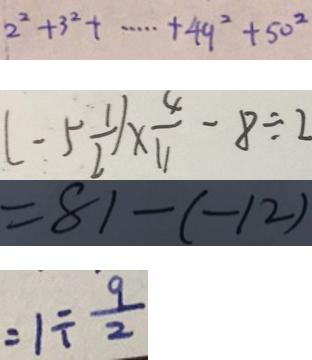Convert formula to latex. <formula><loc_0><loc_0><loc_500><loc_500>2 ^ { 2 } + 3 ^ { 2 } + \cdots + 4 9 ^ { 2 } + 5 0 ^ { 2 } 
 ( - 5 \frac { 1 } { 2 } ) \times \frac { 4 } { 1 1 } - 8 \div 2 
 = 8 1 - ( - 1 2 ) 
 = 1 \div \frac { 9 } { 2 }</formula> 